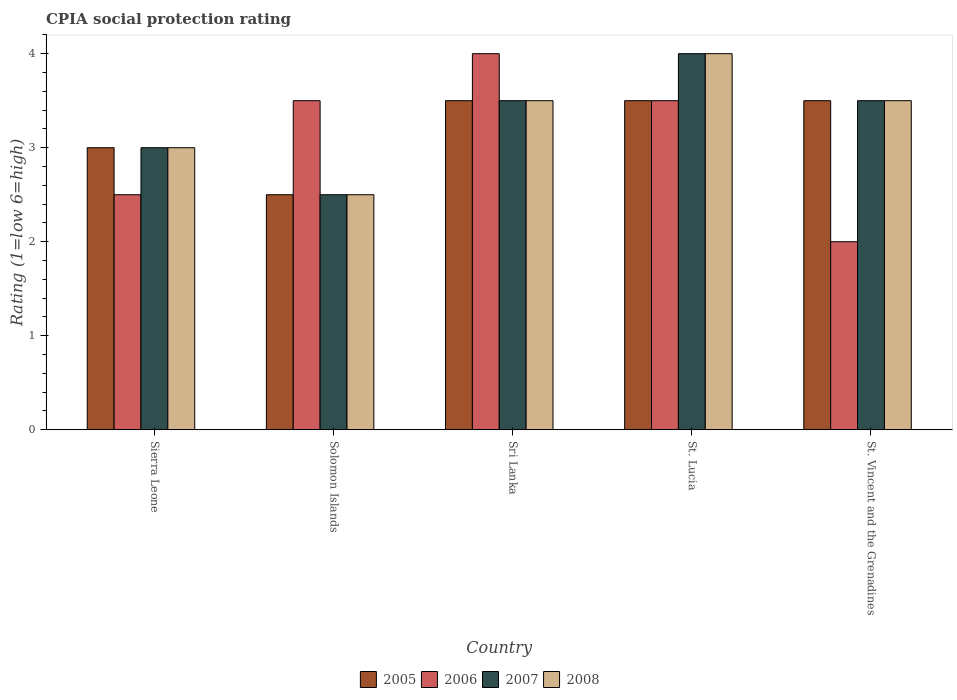How many different coloured bars are there?
Give a very brief answer. 4. How many groups of bars are there?
Your answer should be compact. 5. Are the number of bars per tick equal to the number of legend labels?
Provide a succinct answer. Yes. Are the number of bars on each tick of the X-axis equal?
Your answer should be compact. Yes. How many bars are there on the 1st tick from the left?
Provide a succinct answer. 4. How many bars are there on the 5th tick from the right?
Give a very brief answer. 4. What is the label of the 1st group of bars from the left?
Give a very brief answer. Sierra Leone. In how many cases, is the number of bars for a given country not equal to the number of legend labels?
Offer a very short reply. 0. In which country was the CPIA rating in 2005 maximum?
Provide a succinct answer. Sri Lanka. In which country was the CPIA rating in 2007 minimum?
Your answer should be very brief. Solomon Islands. What is the difference between the CPIA rating in 2005 in Solomon Islands and that in Sri Lanka?
Offer a very short reply. -1. What is the average CPIA rating in 2007 per country?
Keep it short and to the point. 3.3. What is the difference between the CPIA rating of/in 2006 and CPIA rating of/in 2008 in Solomon Islands?
Make the answer very short. 1. In how many countries, is the CPIA rating in 2008 greater than 2.2?
Give a very brief answer. 5. Is the CPIA rating in 2008 in Sierra Leone less than that in Solomon Islands?
Keep it short and to the point. No. What is the difference between the highest and the lowest CPIA rating in 2005?
Ensure brevity in your answer.  1. Is it the case that in every country, the sum of the CPIA rating in 2006 and CPIA rating in 2007 is greater than the sum of CPIA rating in 2008 and CPIA rating in 2005?
Offer a terse response. No. What is the difference between two consecutive major ticks on the Y-axis?
Provide a succinct answer. 1. Are the values on the major ticks of Y-axis written in scientific E-notation?
Give a very brief answer. No. Does the graph contain grids?
Keep it short and to the point. No. Where does the legend appear in the graph?
Provide a succinct answer. Bottom center. What is the title of the graph?
Offer a terse response. CPIA social protection rating. Does "1976" appear as one of the legend labels in the graph?
Provide a short and direct response. No. What is the Rating (1=low 6=high) in 2007 in Sierra Leone?
Provide a short and direct response. 3. What is the Rating (1=low 6=high) of 2006 in Solomon Islands?
Your response must be concise. 3.5. What is the Rating (1=low 6=high) of 2007 in Solomon Islands?
Offer a very short reply. 2.5. What is the Rating (1=low 6=high) of 2006 in St. Lucia?
Provide a succinct answer. 3.5. What is the Rating (1=low 6=high) in 2007 in St. Lucia?
Your answer should be very brief. 4. What is the Rating (1=low 6=high) of 2008 in St. Lucia?
Your answer should be very brief. 4. What is the Rating (1=low 6=high) of 2005 in St. Vincent and the Grenadines?
Make the answer very short. 3.5. What is the Rating (1=low 6=high) of 2007 in St. Vincent and the Grenadines?
Provide a short and direct response. 3.5. What is the Rating (1=low 6=high) in 2008 in St. Vincent and the Grenadines?
Keep it short and to the point. 3.5. Across all countries, what is the maximum Rating (1=low 6=high) of 2005?
Offer a terse response. 3.5. Across all countries, what is the maximum Rating (1=low 6=high) in 2007?
Give a very brief answer. 4. Across all countries, what is the maximum Rating (1=low 6=high) of 2008?
Give a very brief answer. 4. Across all countries, what is the minimum Rating (1=low 6=high) in 2005?
Ensure brevity in your answer.  2.5. Across all countries, what is the minimum Rating (1=low 6=high) of 2006?
Your answer should be compact. 2. What is the total Rating (1=low 6=high) of 2005 in the graph?
Your response must be concise. 16. What is the total Rating (1=low 6=high) of 2006 in the graph?
Offer a very short reply. 15.5. What is the total Rating (1=low 6=high) of 2008 in the graph?
Provide a short and direct response. 16.5. What is the difference between the Rating (1=low 6=high) in 2005 in Sierra Leone and that in Solomon Islands?
Ensure brevity in your answer.  0.5. What is the difference between the Rating (1=low 6=high) of 2006 in Sierra Leone and that in Solomon Islands?
Offer a terse response. -1. What is the difference between the Rating (1=low 6=high) of 2007 in Sierra Leone and that in Solomon Islands?
Your answer should be very brief. 0.5. What is the difference between the Rating (1=low 6=high) in 2005 in Sierra Leone and that in Sri Lanka?
Provide a succinct answer. -0.5. What is the difference between the Rating (1=low 6=high) of 2007 in Sierra Leone and that in Sri Lanka?
Your answer should be compact. -0.5. What is the difference between the Rating (1=low 6=high) in 2008 in Sierra Leone and that in Sri Lanka?
Offer a very short reply. -0.5. What is the difference between the Rating (1=low 6=high) in 2005 in Sierra Leone and that in St. Lucia?
Give a very brief answer. -0.5. What is the difference between the Rating (1=low 6=high) of 2008 in Sierra Leone and that in St. Lucia?
Ensure brevity in your answer.  -1. What is the difference between the Rating (1=low 6=high) of 2006 in Sierra Leone and that in St. Vincent and the Grenadines?
Keep it short and to the point. 0.5. What is the difference between the Rating (1=low 6=high) in 2005 in Solomon Islands and that in Sri Lanka?
Keep it short and to the point. -1. What is the difference between the Rating (1=low 6=high) of 2005 in Solomon Islands and that in St. Lucia?
Give a very brief answer. -1. What is the difference between the Rating (1=low 6=high) of 2006 in Solomon Islands and that in St. Lucia?
Make the answer very short. 0. What is the difference between the Rating (1=low 6=high) in 2008 in Solomon Islands and that in St. Lucia?
Provide a succinct answer. -1.5. What is the difference between the Rating (1=low 6=high) of 2005 in Solomon Islands and that in St. Vincent and the Grenadines?
Provide a succinct answer. -1. What is the difference between the Rating (1=low 6=high) of 2007 in Solomon Islands and that in St. Vincent and the Grenadines?
Offer a terse response. -1. What is the difference between the Rating (1=low 6=high) of 2008 in Solomon Islands and that in St. Vincent and the Grenadines?
Ensure brevity in your answer.  -1. What is the difference between the Rating (1=low 6=high) in 2005 in Sri Lanka and that in St. Lucia?
Offer a terse response. 0. What is the difference between the Rating (1=low 6=high) in 2006 in Sri Lanka and that in St. Vincent and the Grenadines?
Ensure brevity in your answer.  2. What is the difference between the Rating (1=low 6=high) in 2006 in St. Lucia and that in St. Vincent and the Grenadines?
Your response must be concise. 1.5. What is the difference between the Rating (1=low 6=high) of 2007 in St. Lucia and that in St. Vincent and the Grenadines?
Your answer should be compact. 0.5. What is the difference between the Rating (1=low 6=high) in 2005 in Sierra Leone and the Rating (1=low 6=high) in 2006 in Solomon Islands?
Offer a terse response. -0.5. What is the difference between the Rating (1=low 6=high) in 2005 in Sierra Leone and the Rating (1=low 6=high) in 2008 in Solomon Islands?
Provide a succinct answer. 0.5. What is the difference between the Rating (1=low 6=high) of 2006 in Sierra Leone and the Rating (1=low 6=high) of 2007 in Solomon Islands?
Give a very brief answer. 0. What is the difference between the Rating (1=low 6=high) in 2005 in Sierra Leone and the Rating (1=low 6=high) in 2006 in Sri Lanka?
Make the answer very short. -1. What is the difference between the Rating (1=low 6=high) in 2005 in Sierra Leone and the Rating (1=low 6=high) in 2007 in Sri Lanka?
Your answer should be compact. -0.5. What is the difference between the Rating (1=low 6=high) of 2007 in Sierra Leone and the Rating (1=low 6=high) of 2008 in Sri Lanka?
Offer a very short reply. -0.5. What is the difference between the Rating (1=low 6=high) of 2005 in Sierra Leone and the Rating (1=low 6=high) of 2006 in St. Lucia?
Make the answer very short. -0.5. What is the difference between the Rating (1=low 6=high) of 2005 in Sierra Leone and the Rating (1=low 6=high) of 2008 in St. Lucia?
Provide a short and direct response. -1. What is the difference between the Rating (1=low 6=high) in 2005 in Sierra Leone and the Rating (1=low 6=high) in 2006 in St. Vincent and the Grenadines?
Offer a very short reply. 1. What is the difference between the Rating (1=low 6=high) in 2005 in Sierra Leone and the Rating (1=low 6=high) in 2007 in St. Vincent and the Grenadines?
Ensure brevity in your answer.  -0.5. What is the difference between the Rating (1=low 6=high) in 2005 in Sierra Leone and the Rating (1=low 6=high) in 2008 in St. Vincent and the Grenadines?
Your answer should be very brief. -0.5. What is the difference between the Rating (1=low 6=high) of 2006 in Sierra Leone and the Rating (1=low 6=high) of 2007 in St. Vincent and the Grenadines?
Provide a succinct answer. -1. What is the difference between the Rating (1=low 6=high) in 2006 in Sierra Leone and the Rating (1=low 6=high) in 2008 in St. Vincent and the Grenadines?
Keep it short and to the point. -1. What is the difference between the Rating (1=low 6=high) in 2005 in Solomon Islands and the Rating (1=low 6=high) in 2006 in Sri Lanka?
Ensure brevity in your answer.  -1.5. What is the difference between the Rating (1=low 6=high) of 2005 in Solomon Islands and the Rating (1=low 6=high) of 2007 in Sri Lanka?
Offer a very short reply. -1. What is the difference between the Rating (1=low 6=high) in 2006 in Solomon Islands and the Rating (1=low 6=high) in 2007 in Sri Lanka?
Your answer should be compact. 0. What is the difference between the Rating (1=low 6=high) of 2005 in Solomon Islands and the Rating (1=low 6=high) of 2007 in St. Lucia?
Your response must be concise. -1.5. What is the difference between the Rating (1=low 6=high) in 2007 in Solomon Islands and the Rating (1=low 6=high) in 2008 in St. Lucia?
Offer a very short reply. -1.5. What is the difference between the Rating (1=low 6=high) in 2006 in Solomon Islands and the Rating (1=low 6=high) in 2007 in St. Vincent and the Grenadines?
Provide a succinct answer. 0. What is the difference between the Rating (1=low 6=high) of 2006 in Solomon Islands and the Rating (1=low 6=high) of 2008 in St. Vincent and the Grenadines?
Give a very brief answer. 0. What is the difference between the Rating (1=low 6=high) in 2005 in Sri Lanka and the Rating (1=low 6=high) in 2006 in St. Lucia?
Offer a very short reply. 0. What is the difference between the Rating (1=low 6=high) of 2005 in Sri Lanka and the Rating (1=low 6=high) of 2008 in St. Lucia?
Your response must be concise. -0.5. What is the difference between the Rating (1=low 6=high) in 2006 in Sri Lanka and the Rating (1=low 6=high) in 2008 in St. Lucia?
Your response must be concise. 0. What is the difference between the Rating (1=low 6=high) of 2007 in Sri Lanka and the Rating (1=low 6=high) of 2008 in St. Lucia?
Provide a short and direct response. -0.5. What is the difference between the Rating (1=low 6=high) of 2005 in Sri Lanka and the Rating (1=low 6=high) of 2007 in St. Vincent and the Grenadines?
Make the answer very short. 0. What is the difference between the Rating (1=low 6=high) of 2005 in Sri Lanka and the Rating (1=low 6=high) of 2008 in St. Vincent and the Grenadines?
Give a very brief answer. 0. What is the difference between the Rating (1=low 6=high) in 2006 in Sri Lanka and the Rating (1=low 6=high) in 2008 in St. Vincent and the Grenadines?
Offer a very short reply. 0.5. What is the difference between the Rating (1=low 6=high) in 2005 in St. Lucia and the Rating (1=low 6=high) in 2006 in St. Vincent and the Grenadines?
Provide a succinct answer. 1.5. What is the difference between the Rating (1=low 6=high) of 2006 in St. Lucia and the Rating (1=low 6=high) of 2007 in St. Vincent and the Grenadines?
Provide a succinct answer. 0. What is the difference between the Rating (1=low 6=high) in 2006 in St. Lucia and the Rating (1=low 6=high) in 2008 in St. Vincent and the Grenadines?
Your answer should be compact. 0. What is the average Rating (1=low 6=high) in 2005 per country?
Provide a succinct answer. 3.2. What is the average Rating (1=low 6=high) in 2008 per country?
Your answer should be very brief. 3.3. What is the difference between the Rating (1=low 6=high) of 2005 and Rating (1=low 6=high) of 2008 in Sierra Leone?
Your answer should be very brief. 0. What is the difference between the Rating (1=low 6=high) of 2006 and Rating (1=low 6=high) of 2008 in Sierra Leone?
Give a very brief answer. -0.5. What is the difference between the Rating (1=low 6=high) of 2005 and Rating (1=low 6=high) of 2007 in Solomon Islands?
Your response must be concise. 0. What is the difference between the Rating (1=low 6=high) in 2005 and Rating (1=low 6=high) in 2008 in Solomon Islands?
Ensure brevity in your answer.  0. What is the difference between the Rating (1=low 6=high) of 2006 and Rating (1=low 6=high) of 2007 in Solomon Islands?
Your answer should be compact. 1. What is the difference between the Rating (1=low 6=high) of 2006 and Rating (1=low 6=high) of 2008 in Solomon Islands?
Your answer should be compact. 1. What is the difference between the Rating (1=low 6=high) of 2005 and Rating (1=low 6=high) of 2006 in Sri Lanka?
Your answer should be very brief. -0.5. What is the difference between the Rating (1=low 6=high) in 2005 and Rating (1=low 6=high) in 2007 in Sri Lanka?
Make the answer very short. 0. What is the difference between the Rating (1=low 6=high) in 2005 and Rating (1=low 6=high) in 2008 in Sri Lanka?
Keep it short and to the point. 0. What is the difference between the Rating (1=low 6=high) in 2006 and Rating (1=low 6=high) in 2007 in Sri Lanka?
Make the answer very short. 0.5. What is the difference between the Rating (1=low 6=high) of 2007 and Rating (1=low 6=high) of 2008 in Sri Lanka?
Provide a succinct answer. 0. What is the difference between the Rating (1=low 6=high) in 2005 and Rating (1=low 6=high) in 2008 in St. Lucia?
Offer a terse response. -0.5. What is the difference between the Rating (1=low 6=high) of 2005 and Rating (1=low 6=high) of 2006 in St. Vincent and the Grenadines?
Make the answer very short. 1.5. What is the difference between the Rating (1=low 6=high) in 2005 and Rating (1=low 6=high) in 2008 in St. Vincent and the Grenadines?
Your answer should be compact. 0. What is the difference between the Rating (1=low 6=high) in 2006 and Rating (1=low 6=high) in 2007 in St. Vincent and the Grenadines?
Your response must be concise. -1.5. What is the ratio of the Rating (1=low 6=high) in 2005 in Sierra Leone to that in Solomon Islands?
Your answer should be compact. 1.2. What is the ratio of the Rating (1=low 6=high) of 2008 in Sierra Leone to that in Solomon Islands?
Your answer should be very brief. 1.2. What is the ratio of the Rating (1=low 6=high) of 2005 in Sierra Leone to that in Sri Lanka?
Give a very brief answer. 0.86. What is the ratio of the Rating (1=low 6=high) in 2006 in Sierra Leone to that in Sri Lanka?
Keep it short and to the point. 0.62. What is the ratio of the Rating (1=low 6=high) of 2007 in Sierra Leone to that in Sri Lanka?
Your answer should be compact. 0.86. What is the ratio of the Rating (1=low 6=high) of 2008 in Sierra Leone to that in Sri Lanka?
Provide a short and direct response. 0.86. What is the ratio of the Rating (1=low 6=high) of 2005 in Sierra Leone to that in St. Lucia?
Your answer should be very brief. 0.86. What is the ratio of the Rating (1=low 6=high) in 2006 in Sierra Leone to that in St. Vincent and the Grenadines?
Ensure brevity in your answer.  1.25. What is the ratio of the Rating (1=low 6=high) of 2005 in Solomon Islands to that in Sri Lanka?
Ensure brevity in your answer.  0.71. What is the ratio of the Rating (1=low 6=high) in 2006 in Solomon Islands to that in Sri Lanka?
Give a very brief answer. 0.88. What is the ratio of the Rating (1=low 6=high) in 2005 in Solomon Islands to that in St. Lucia?
Your answer should be very brief. 0.71. What is the ratio of the Rating (1=low 6=high) in 2006 in Solomon Islands to that in St. Lucia?
Your response must be concise. 1. What is the ratio of the Rating (1=low 6=high) in 2007 in Solomon Islands to that in St. Lucia?
Your response must be concise. 0.62. What is the ratio of the Rating (1=low 6=high) in 2008 in Solomon Islands to that in St. Lucia?
Your response must be concise. 0.62. What is the ratio of the Rating (1=low 6=high) in 2006 in Solomon Islands to that in St. Vincent and the Grenadines?
Give a very brief answer. 1.75. What is the ratio of the Rating (1=low 6=high) in 2007 in Solomon Islands to that in St. Vincent and the Grenadines?
Give a very brief answer. 0.71. What is the ratio of the Rating (1=low 6=high) of 2008 in Solomon Islands to that in St. Vincent and the Grenadines?
Offer a very short reply. 0.71. What is the ratio of the Rating (1=low 6=high) of 2005 in Sri Lanka to that in St. Lucia?
Provide a succinct answer. 1. What is the ratio of the Rating (1=low 6=high) of 2006 in Sri Lanka to that in St. Lucia?
Make the answer very short. 1.14. What is the ratio of the Rating (1=low 6=high) in 2007 in Sri Lanka to that in St. Lucia?
Keep it short and to the point. 0.88. What is the ratio of the Rating (1=low 6=high) of 2008 in Sri Lanka to that in St. Lucia?
Give a very brief answer. 0.88. What is the ratio of the Rating (1=low 6=high) of 2005 in Sri Lanka to that in St. Vincent and the Grenadines?
Provide a short and direct response. 1. What is the ratio of the Rating (1=low 6=high) in 2006 in Sri Lanka to that in St. Vincent and the Grenadines?
Offer a very short reply. 2. What is the ratio of the Rating (1=low 6=high) in 2006 in St. Lucia to that in St. Vincent and the Grenadines?
Your answer should be compact. 1.75. What is the difference between the highest and the lowest Rating (1=low 6=high) in 2005?
Your answer should be compact. 1. What is the difference between the highest and the lowest Rating (1=low 6=high) in 2007?
Provide a short and direct response. 1.5. What is the difference between the highest and the lowest Rating (1=low 6=high) in 2008?
Your response must be concise. 1.5. 